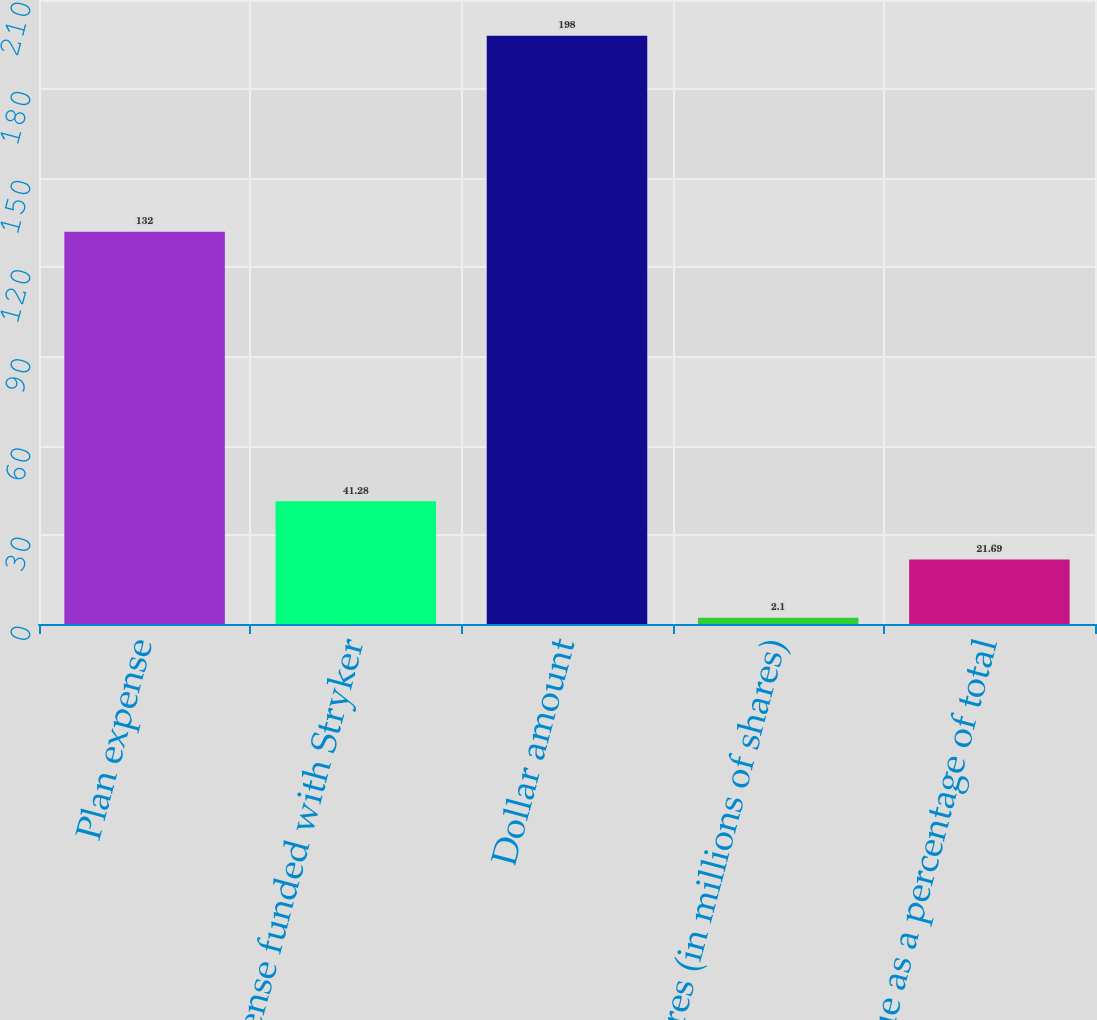Convert chart. <chart><loc_0><loc_0><loc_500><loc_500><bar_chart><fcel>Plan expense<fcel>Expense funded with Stryker<fcel>Dollar amount<fcel>Shares (in millions of shares)<fcel>Value as a percentage of total<nl><fcel>132<fcel>41.28<fcel>198<fcel>2.1<fcel>21.69<nl></chart> 